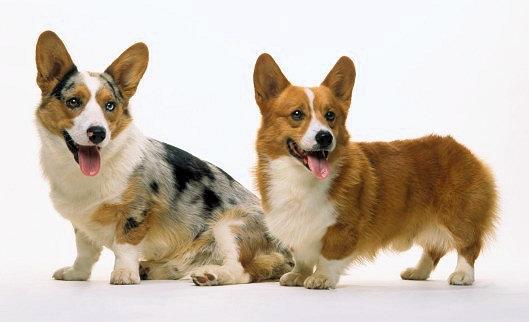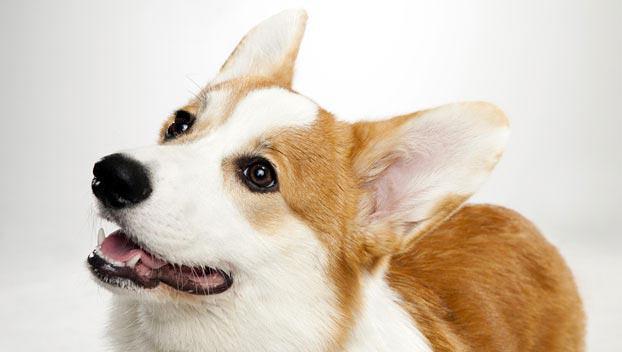The first image is the image on the left, the second image is the image on the right. For the images displayed, is the sentence "One image has exactly one dog." factually correct? Answer yes or no. Yes. The first image is the image on the left, the second image is the image on the right. Evaluate the accuracy of this statement regarding the images: "There are three dogs". Is it true? Answer yes or no. Yes. 